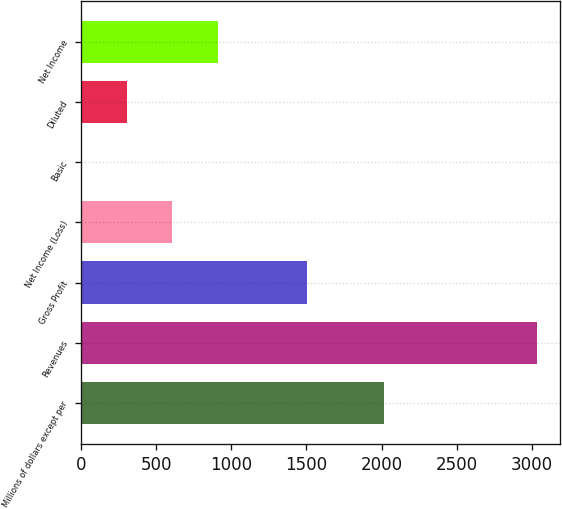Convert chart. <chart><loc_0><loc_0><loc_500><loc_500><bar_chart><fcel>Millions of dollars except per<fcel>Revenues<fcel>Gross Profit<fcel>Net Income (Loss)<fcel>Basic<fcel>Diluted<fcel>Net Income<nl><fcel>2017<fcel>3035<fcel>1504<fcel>607.61<fcel>0.75<fcel>304.18<fcel>911.04<nl></chart> 